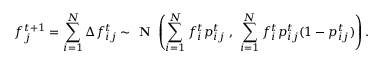<formula> <loc_0><loc_0><loc_500><loc_500>f _ { j } ^ { t + 1 } = \sum _ { i = 1 } ^ { N } \Delta f _ { i j } ^ { t } \sim N \left ( \sum _ { i = 1 } ^ { N } f _ { i } ^ { t } { p } _ { i j } ^ { t } \ , \ \sum _ { i = 1 } ^ { N } f _ { i } ^ { t } { p } _ { i j } ^ { t } ( 1 - { p } _ { i j } ^ { t } ) \right ) .</formula> 